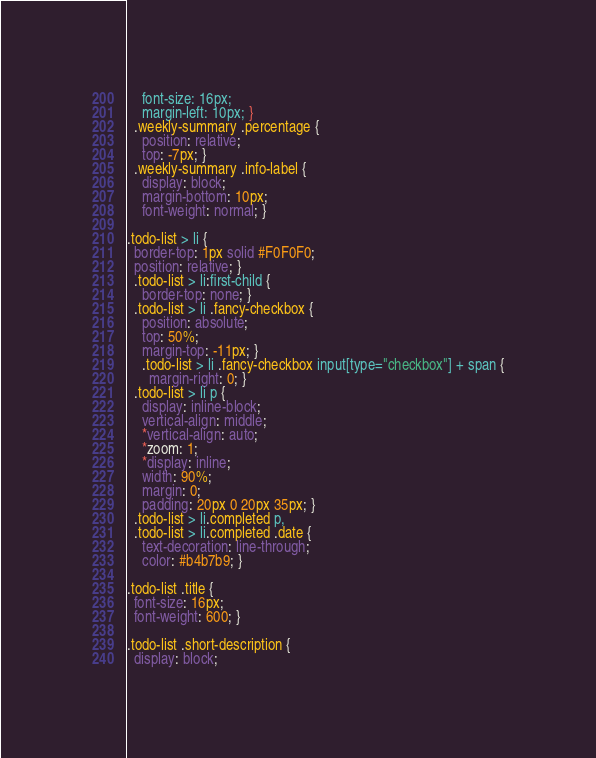<code> <loc_0><loc_0><loc_500><loc_500><_CSS_>    font-size: 16px;
    margin-left: 10px; }
  .weekly-summary .percentage {
    position: relative;
    top: -7px; }
  .weekly-summary .info-label {
    display: block;
    margin-bottom: 10px;
    font-weight: normal; }

.todo-list > li {
  border-top: 1px solid #F0F0F0;
  position: relative; }
  .todo-list > li:first-child {
    border-top: none; }
  .todo-list > li .fancy-checkbox {
    position: absolute;
    top: 50%;
    margin-top: -11px; }
    .todo-list > li .fancy-checkbox input[type="checkbox"] + span {
      margin-right: 0; }
  .todo-list > li p {
    display: inline-block;
    vertical-align: middle;
    *vertical-align: auto;
    *zoom: 1;
    *display: inline;
    width: 90%;
    margin: 0;
    padding: 20px 0 20px 35px; }
  .todo-list > li.completed p,
  .todo-list > li.completed .date {
    text-decoration: line-through;
    color: #b4b7b9; }

.todo-list .title {
  font-size: 16px;
  font-weight: 600; }

.todo-list .short-description {
  display: block;</code> 